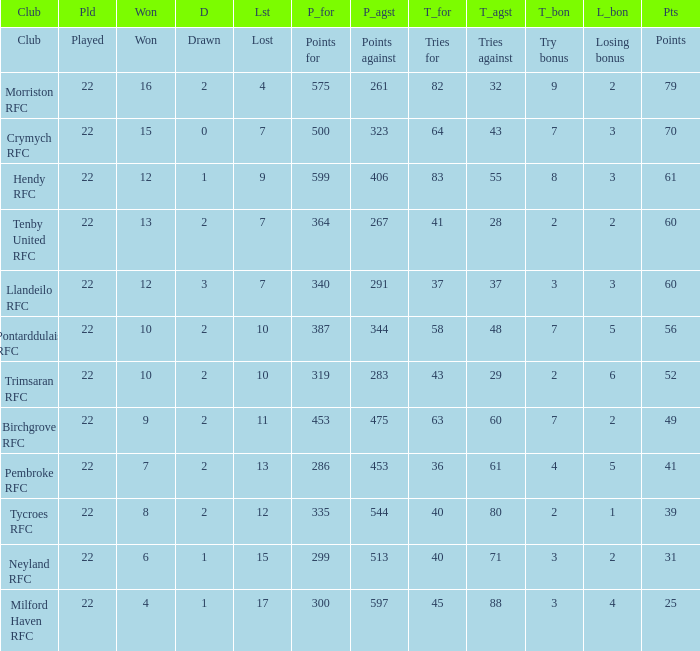 how many points against with tries for being 43 1.0. 